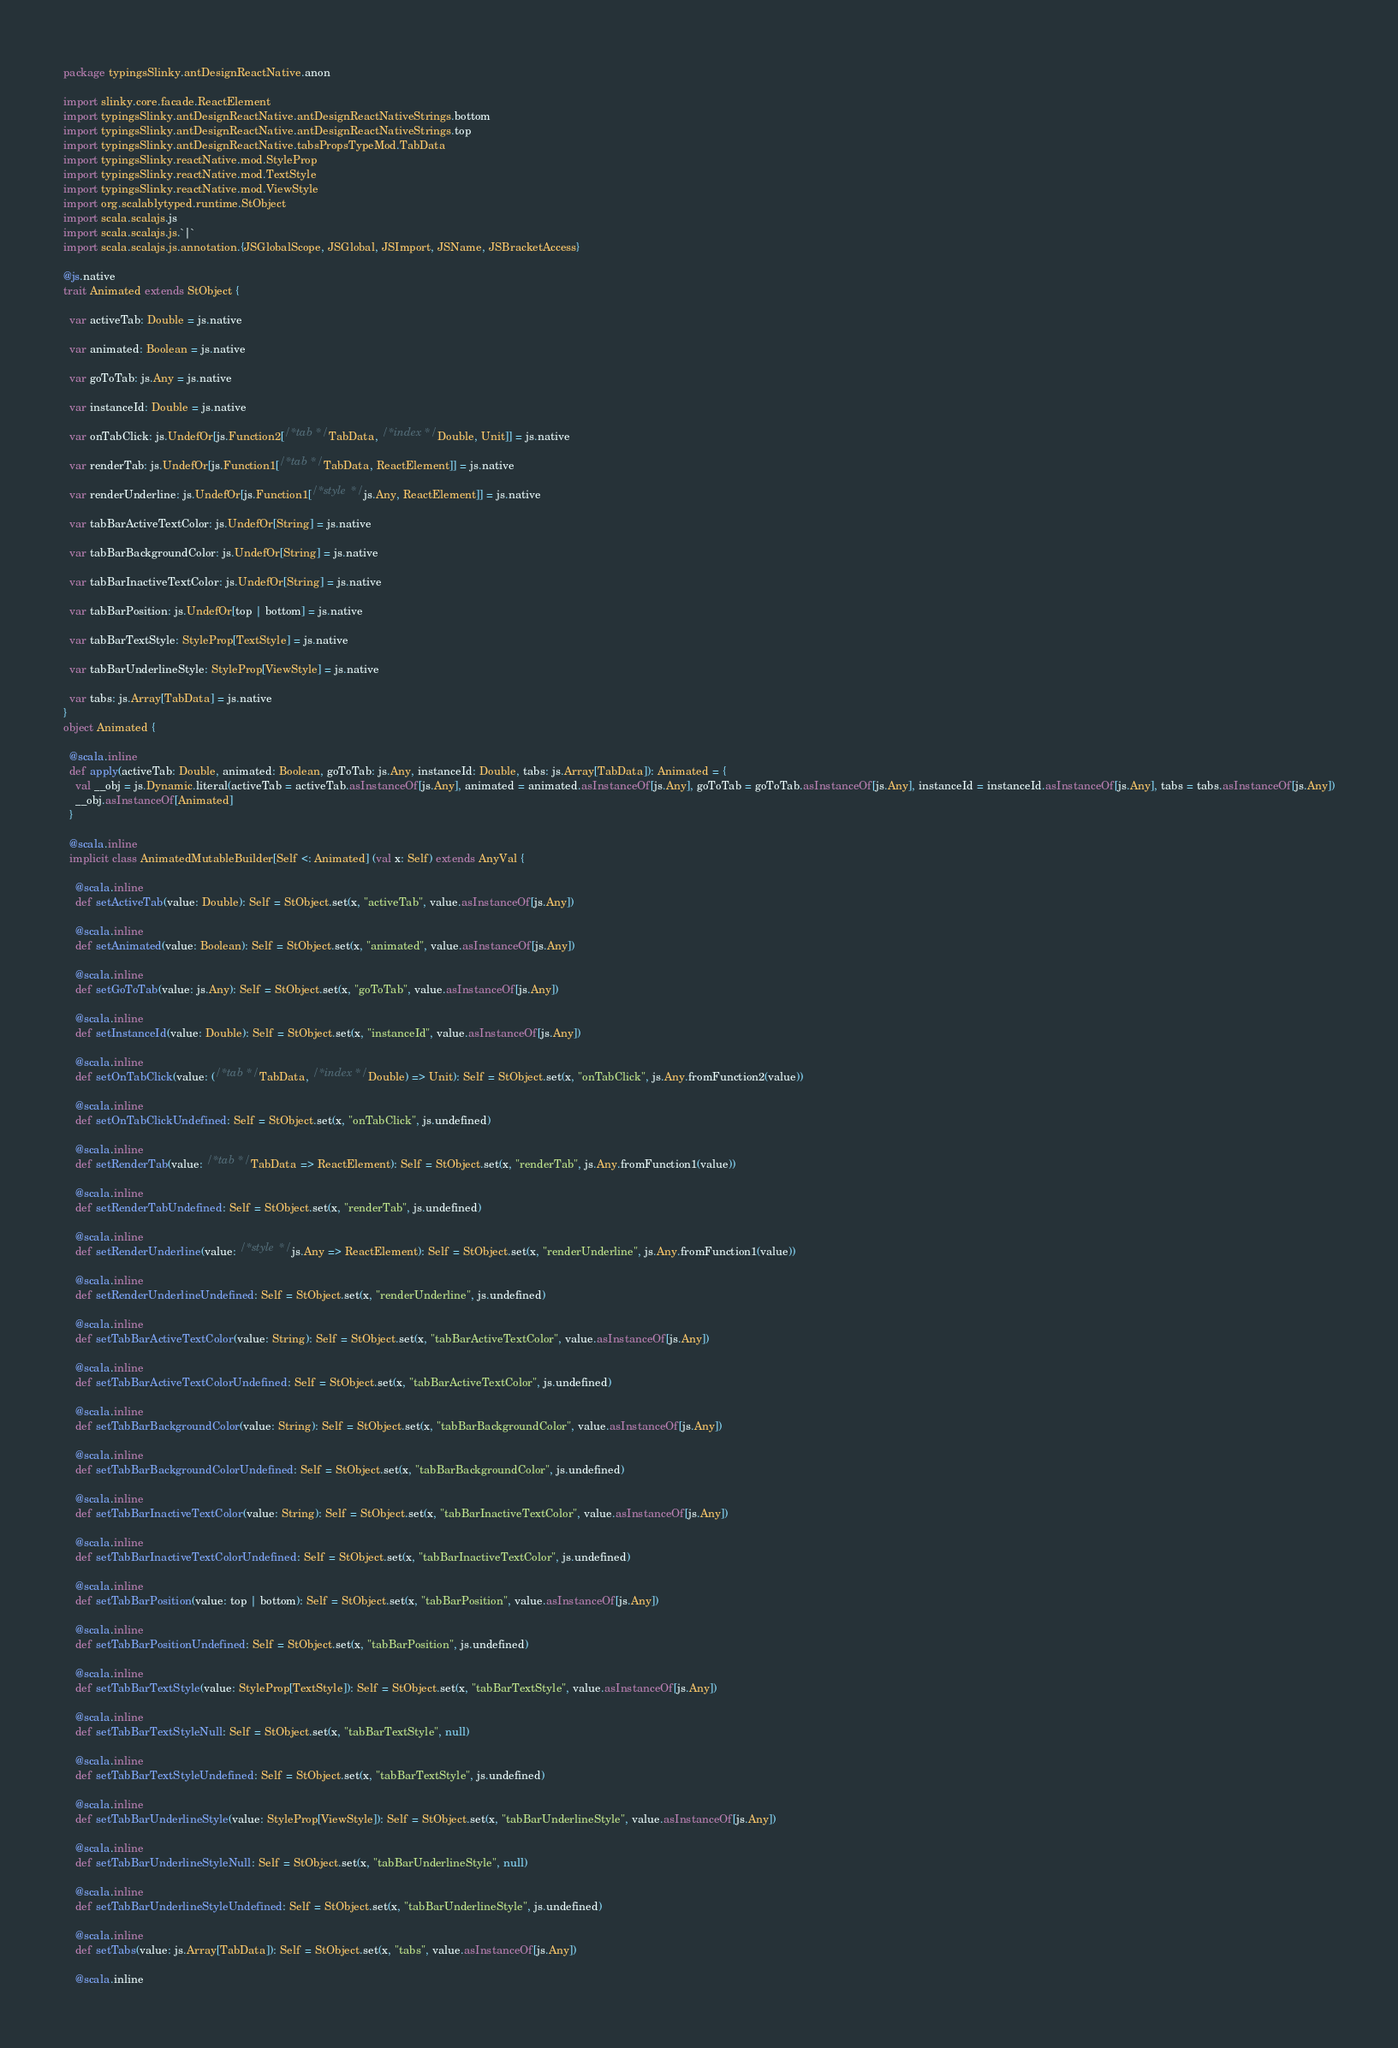Convert code to text. <code><loc_0><loc_0><loc_500><loc_500><_Scala_>package typingsSlinky.antDesignReactNative.anon

import slinky.core.facade.ReactElement
import typingsSlinky.antDesignReactNative.antDesignReactNativeStrings.bottom
import typingsSlinky.antDesignReactNative.antDesignReactNativeStrings.top
import typingsSlinky.antDesignReactNative.tabsPropsTypeMod.TabData
import typingsSlinky.reactNative.mod.StyleProp
import typingsSlinky.reactNative.mod.TextStyle
import typingsSlinky.reactNative.mod.ViewStyle
import org.scalablytyped.runtime.StObject
import scala.scalajs.js
import scala.scalajs.js.`|`
import scala.scalajs.js.annotation.{JSGlobalScope, JSGlobal, JSImport, JSName, JSBracketAccess}

@js.native
trait Animated extends StObject {
  
  var activeTab: Double = js.native
  
  var animated: Boolean = js.native
  
  var goToTab: js.Any = js.native
  
  var instanceId: Double = js.native
  
  var onTabClick: js.UndefOr[js.Function2[/* tab */ TabData, /* index */ Double, Unit]] = js.native
  
  var renderTab: js.UndefOr[js.Function1[/* tab */ TabData, ReactElement]] = js.native
  
  var renderUnderline: js.UndefOr[js.Function1[/* style */ js.Any, ReactElement]] = js.native
  
  var tabBarActiveTextColor: js.UndefOr[String] = js.native
  
  var tabBarBackgroundColor: js.UndefOr[String] = js.native
  
  var tabBarInactiveTextColor: js.UndefOr[String] = js.native
  
  var tabBarPosition: js.UndefOr[top | bottom] = js.native
  
  var tabBarTextStyle: StyleProp[TextStyle] = js.native
  
  var tabBarUnderlineStyle: StyleProp[ViewStyle] = js.native
  
  var tabs: js.Array[TabData] = js.native
}
object Animated {
  
  @scala.inline
  def apply(activeTab: Double, animated: Boolean, goToTab: js.Any, instanceId: Double, tabs: js.Array[TabData]): Animated = {
    val __obj = js.Dynamic.literal(activeTab = activeTab.asInstanceOf[js.Any], animated = animated.asInstanceOf[js.Any], goToTab = goToTab.asInstanceOf[js.Any], instanceId = instanceId.asInstanceOf[js.Any], tabs = tabs.asInstanceOf[js.Any])
    __obj.asInstanceOf[Animated]
  }
  
  @scala.inline
  implicit class AnimatedMutableBuilder[Self <: Animated] (val x: Self) extends AnyVal {
    
    @scala.inline
    def setActiveTab(value: Double): Self = StObject.set(x, "activeTab", value.asInstanceOf[js.Any])
    
    @scala.inline
    def setAnimated(value: Boolean): Self = StObject.set(x, "animated", value.asInstanceOf[js.Any])
    
    @scala.inline
    def setGoToTab(value: js.Any): Self = StObject.set(x, "goToTab", value.asInstanceOf[js.Any])
    
    @scala.inline
    def setInstanceId(value: Double): Self = StObject.set(x, "instanceId", value.asInstanceOf[js.Any])
    
    @scala.inline
    def setOnTabClick(value: (/* tab */ TabData, /* index */ Double) => Unit): Self = StObject.set(x, "onTabClick", js.Any.fromFunction2(value))
    
    @scala.inline
    def setOnTabClickUndefined: Self = StObject.set(x, "onTabClick", js.undefined)
    
    @scala.inline
    def setRenderTab(value: /* tab */ TabData => ReactElement): Self = StObject.set(x, "renderTab", js.Any.fromFunction1(value))
    
    @scala.inline
    def setRenderTabUndefined: Self = StObject.set(x, "renderTab", js.undefined)
    
    @scala.inline
    def setRenderUnderline(value: /* style */ js.Any => ReactElement): Self = StObject.set(x, "renderUnderline", js.Any.fromFunction1(value))
    
    @scala.inline
    def setRenderUnderlineUndefined: Self = StObject.set(x, "renderUnderline", js.undefined)
    
    @scala.inline
    def setTabBarActiveTextColor(value: String): Self = StObject.set(x, "tabBarActiveTextColor", value.asInstanceOf[js.Any])
    
    @scala.inline
    def setTabBarActiveTextColorUndefined: Self = StObject.set(x, "tabBarActiveTextColor", js.undefined)
    
    @scala.inline
    def setTabBarBackgroundColor(value: String): Self = StObject.set(x, "tabBarBackgroundColor", value.asInstanceOf[js.Any])
    
    @scala.inline
    def setTabBarBackgroundColorUndefined: Self = StObject.set(x, "tabBarBackgroundColor", js.undefined)
    
    @scala.inline
    def setTabBarInactiveTextColor(value: String): Self = StObject.set(x, "tabBarInactiveTextColor", value.asInstanceOf[js.Any])
    
    @scala.inline
    def setTabBarInactiveTextColorUndefined: Self = StObject.set(x, "tabBarInactiveTextColor", js.undefined)
    
    @scala.inline
    def setTabBarPosition(value: top | bottom): Self = StObject.set(x, "tabBarPosition", value.asInstanceOf[js.Any])
    
    @scala.inline
    def setTabBarPositionUndefined: Self = StObject.set(x, "tabBarPosition", js.undefined)
    
    @scala.inline
    def setTabBarTextStyle(value: StyleProp[TextStyle]): Self = StObject.set(x, "tabBarTextStyle", value.asInstanceOf[js.Any])
    
    @scala.inline
    def setTabBarTextStyleNull: Self = StObject.set(x, "tabBarTextStyle", null)
    
    @scala.inline
    def setTabBarTextStyleUndefined: Self = StObject.set(x, "tabBarTextStyle", js.undefined)
    
    @scala.inline
    def setTabBarUnderlineStyle(value: StyleProp[ViewStyle]): Self = StObject.set(x, "tabBarUnderlineStyle", value.asInstanceOf[js.Any])
    
    @scala.inline
    def setTabBarUnderlineStyleNull: Self = StObject.set(x, "tabBarUnderlineStyle", null)
    
    @scala.inline
    def setTabBarUnderlineStyleUndefined: Self = StObject.set(x, "tabBarUnderlineStyle", js.undefined)
    
    @scala.inline
    def setTabs(value: js.Array[TabData]): Self = StObject.set(x, "tabs", value.asInstanceOf[js.Any])
    
    @scala.inline</code> 